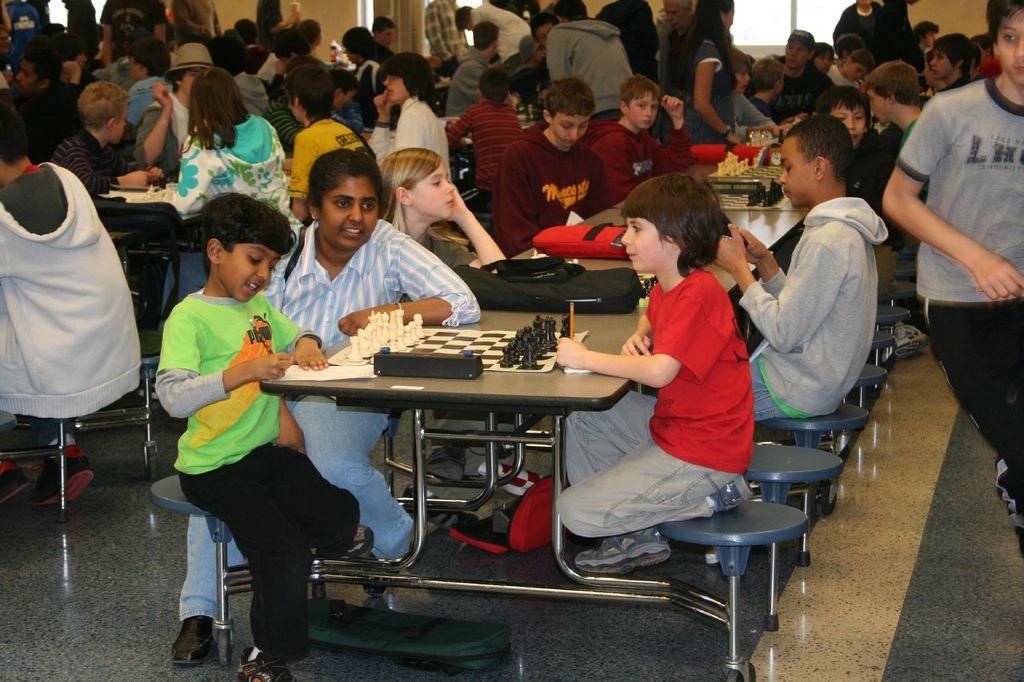How many people are in the image? There is a group of people in the image. What are the people doing in the image? Some people are seated on chairs, while others are standing in front of the seated people. What is on the table in the image? There are bags on the table. What game is being played in the image? There is a chess board in the image, suggesting that a game of chess is being played. What type of silk is being used to play the game in the image? There is no silk present in the image, and the game being played is chess, which does not involve silk. 